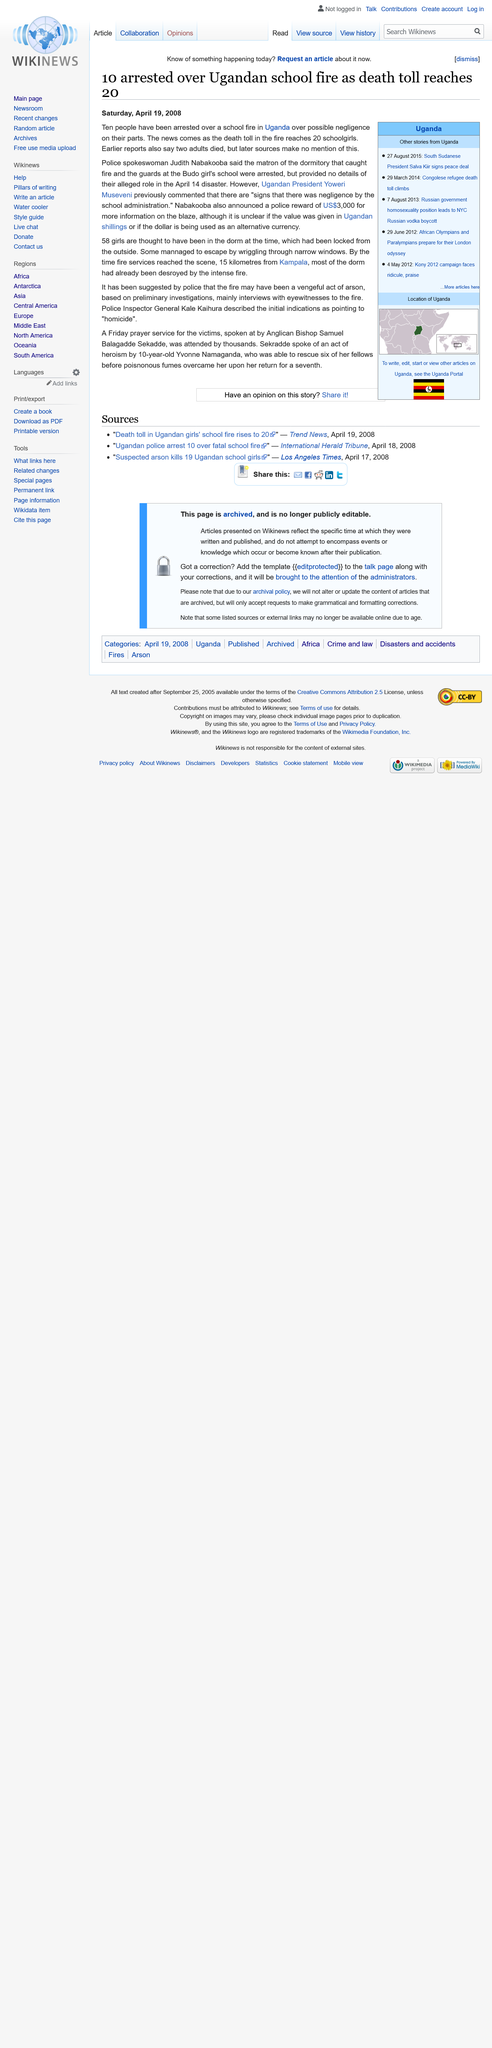Draw attention to some important aspects in this diagram. The fire was started as an act of vengeful arson, as suggested by the police. Ten individuals have been taken into custody in relation to the fire in Uganda. There were a total of 58 girls living in the dormitory, and of those, 20 were reported to have passed away. 